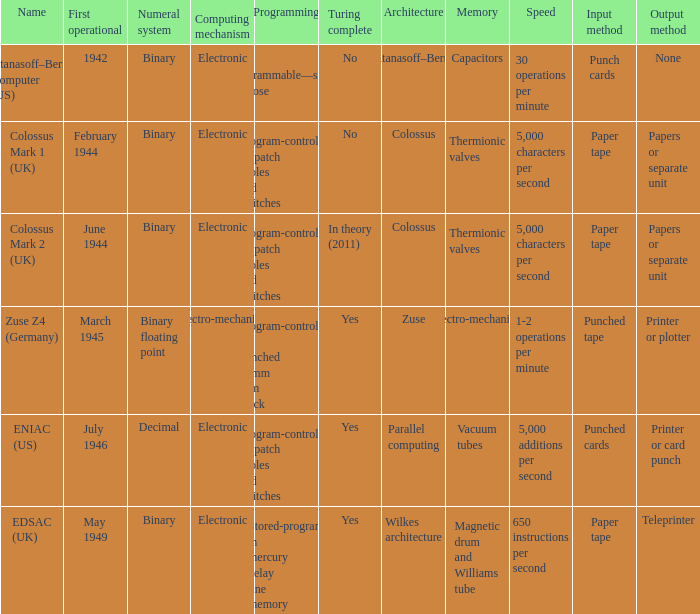Would you mind parsing the complete table? {'header': ['Name', 'First operational', 'Numeral system', 'Computing mechanism', 'Programming', 'Turing complete', 'Architecture', 'Memory', 'Speed', 'Input method', 'Output method'], 'rows': [['Atanasoff–Berry Computer (US)', '1942', 'Binary', 'Electronic', 'Not programmable—single purpose', 'No', 'Atanasoff–Berry', 'Capacitors', '30 operations per minute', 'Punch cards', 'None'], ['Colossus Mark 1 (UK)', 'February 1944', 'Binary', 'Electronic', 'Program-controlled by patch cables and switches', 'No', 'Colossus', 'Thermionic valves', '5,000 characters per second', 'Paper tape', 'Papers or separate unit'], ['Colossus Mark 2 (UK)', 'June 1944', 'Binary', 'Electronic', 'Program-controlled by patch cables and switches', 'In theory (2011)', 'Colossus', 'Thermionic valves', '5,000 characters per second', 'Paper tape', 'Papers or separate unit'], ['Zuse Z4 (Germany)', 'March 1945', 'Binary floating point', 'Electro-mechanical', 'Program-controlled by punched 35mm film stock', 'Yes', 'Zuse', 'Electro-mechanical', '1-2 operations per minute', 'Punched tape', 'Printer or plotter'], ['ENIAC (US)', 'July 1946', 'Decimal', 'Electronic', 'Program-controlled by patch cables and switches', 'Yes', 'Parallel computing', 'Vacuum tubes', '5,000 additions per second', 'Punched cards', 'Printer or card punch'], ['EDSAC (UK)', 'May 1949', 'Binary', 'Electronic', 'Stored-program in mercury delay line memory', 'Yes', 'Wilkes architecture', 'Magnetic drum and Williams tube', '650 instructions per second', 'Paper tape', 'Teleprinter']]} What's the computing mechanbeingm with name being atanasoff–berry computer (us) Electronic. 